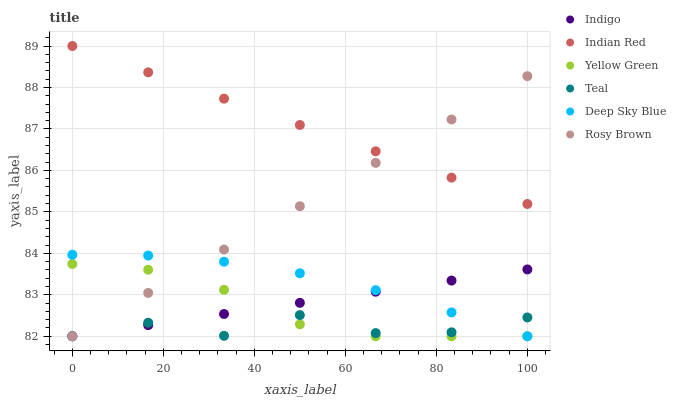Does Teal have the minimum area under the curve?
Answer yes or no. Yes. Does Indian Red have the maximum area under the curve?
Answer yes or no. Yes. Does Deep Sky Blue have the minimum area under the curve?
Answer yes or no. No. Does Deep Sky Blue have the maximum area under the curve?
Answer yes or no. No. Is Rosy Brown the smoothest?
Answer yes or no. Yes. Is Teal the roughest?
Answer yes or no. Yes. Is Deep Sky Blue the smoothest?
Answer yes or no. No. Is Deep Sky Blue the roughest?
Answer yes or no. No. Does Indigo have the lowest value?
Answer yes or no. Yes. Does Indian Red have the lowest value?
Answer yes or no. No. Does Indian Red have the highest value?
Answer yes or no. Yes. Does Deep Sky Blue have the highest value?
Answer yes or no. No. Is Yellow Green less than Indian Red?
Answer yes or no. Yes. Is Indian Red greater than Teal?
Answer yes or no. Yes. Does Rosy Brown intersect Yellow Green?
Answer yes or no. Yes. Is Rosy Brown less than Yellow Green?
Answer yes or no. No. Is Rosy Brown greater than Yellow Green?
Answer yes or no. No. Does Yellow Green intersect Indian Red?
Answer yes or no. No. 